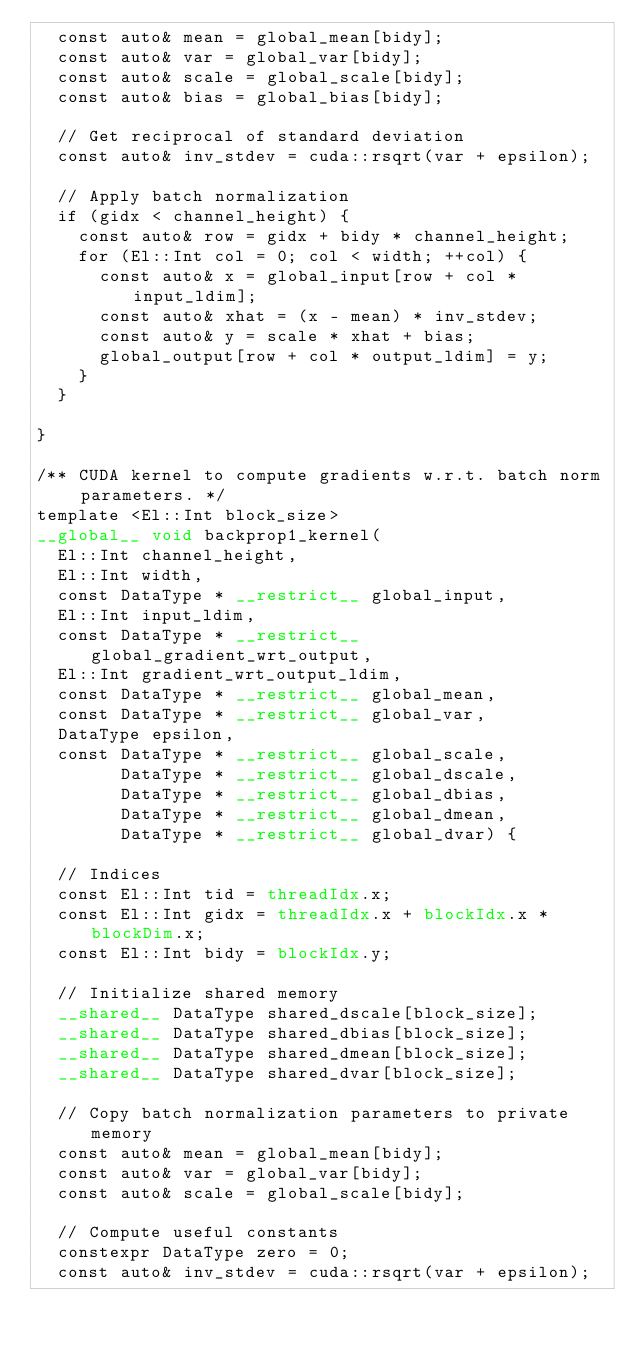Convert code to text. <code><loc_0><loc_0><loc_500><loc_500><_Cuda_>  const auto& mean = global_mean[bidy];
  const auto& var = global_var[bidy];
  const auto& scale = global_scale[bidy];
  const auto& bias = global_bias[bidy];

  // Get reciprocal of standard deviation
  const auto& inv_stdev = cuda::rsqrt(var + epsilon);

  // Apply batch normalization
  if (gidx < channel_height) {
    const auto& row = gidx + bidy * channel_height;
    for (El::Int col = 0; col < width; ++col) {
      const auto& x = global_input[row + col * input_ldim];
      const auto& xhat = (x - mean) * inv_stdev;
      const auto& y = scale * xhat + bias;
      global_output[row + col * output_ldim] = y;
    }
  }

}

/** CUDA kernel to compute gradients w.r.t. batch norm parameters. */
template <El::Int block_size>
__global__ void backprop1_kernel(
  El::Int channel_height,
  El::Int width,
  const DataType * __restrict__ global_input,
  El::Int input_ldim,
  const DataType * __restrict__ global_gradient_wrt_output,
  El::Int gradient_wrt_output_ldim,
  const DataType * __restrict__ global_mean,
  const DataType * __restrict__ global_var,
  DataType epsilon,
  const DataType * __restrict__ global_scale,
        DataType * __restrict__ global_dscale,
        DataType * __restrict__ global_dbias,
        DataType * __restrict__ global_dmean,
        DataType * __restrict__ global_dvar) {

  // Indices
  const El::Int tid = threadIdx.x;
  const El::Int gidx = threadIdx.x + blockIdx.x * blockDim.x;
  const El::Int bidy = blockIdx.y;

  // Initialize shared memory
  __shared__ DataType shared_dscale[block_size];
  __shared__ DataType shared_dbias[block_size];
  __shared__ DataType shared_dmean[block_size];
  __shared__ DataType shared_dvar[block_size];

  // Copy batch normalization parameters to private memory
  const auto& mean = global_mean[bidy];
  const auto& var = global_var[bidy];
  const auto& scale = global_scale[bidy];

  // Compute useful constants
  constexpr DataType zero = 0;
  const auto& inv_stdev = cuda::rsqrt(var + epsilon);</code> 